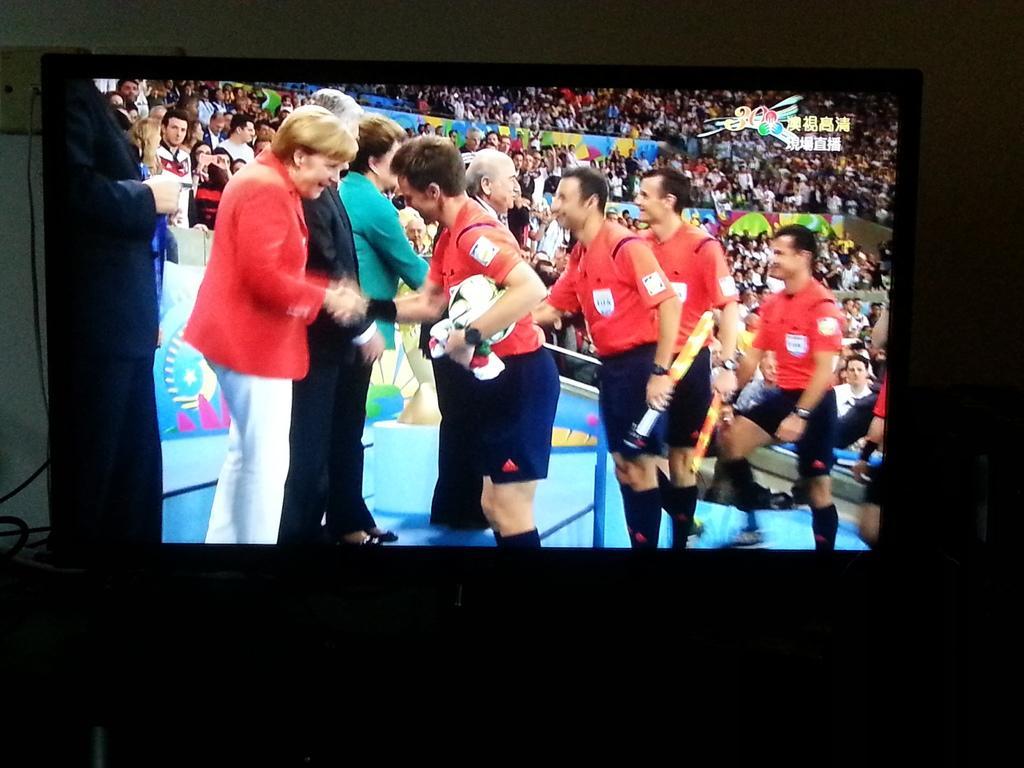Could you give a brief overview of what you see in this image? In this image we can see a television. On television screen we can see a stadium and many people. There are few persons holding some objects in their hands. There is some text and a logo at the top most of the screen. 